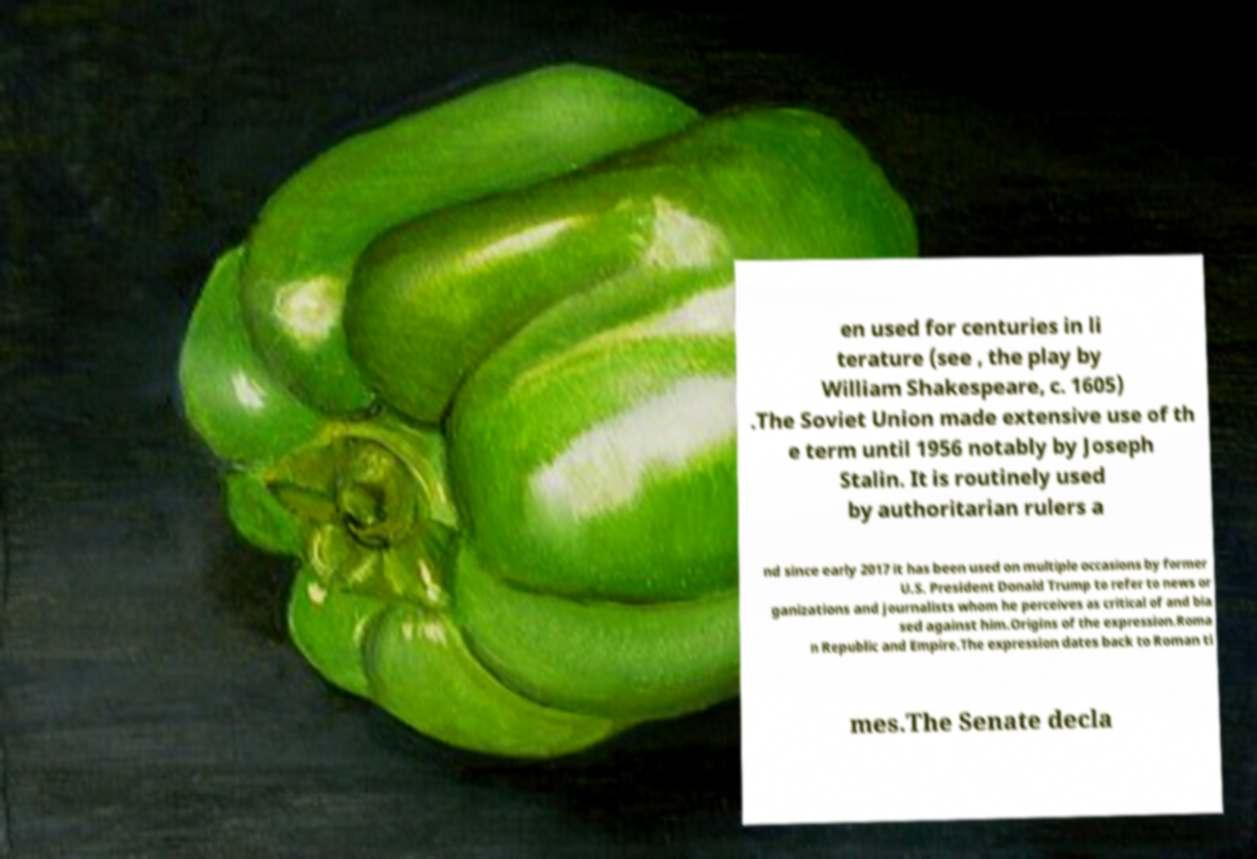Please identify and transcribe the text found in this image. en used for centuries in li terature (see , the play by William Shakespeare, c. 1605) .The Soviet Union made extensive use of th e term until 1956 notably by Joseph Stalin. It is routinely used by authoritarian rulers a nd since early 2017 it has been used on multiple occasions by former U.S. President Donald Trump to refer to news or ganizations and journalists whom he perceives as critical of and bia sed against him.Origins of the expression.Roma n Republic and Empire.The expression dates back to Roman ti mes.The Senate decla 